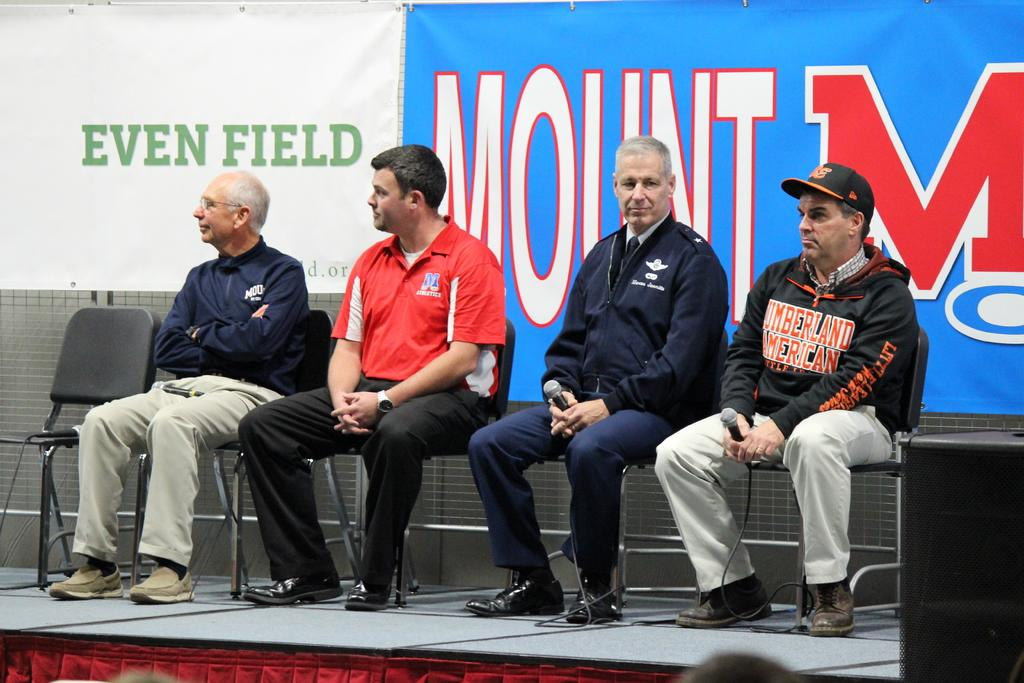How many people are in the image? There is a group of persons in the image. What are the persons in the image doing? The persons are sitting on chairs. What can be seen in the background of the image? There is an advertisement and a wall in the background of the image. What is present in the foreground of the image? There are wires and a dais in the foreground of the image. What type of home can be seen in the image? There is no home present in the image; it features a group of persons sitting on chairs, an advertisement, a wall, wires, and a dais. Can you tell me how many cameras are visible in the image? There is no camera present in the image. 